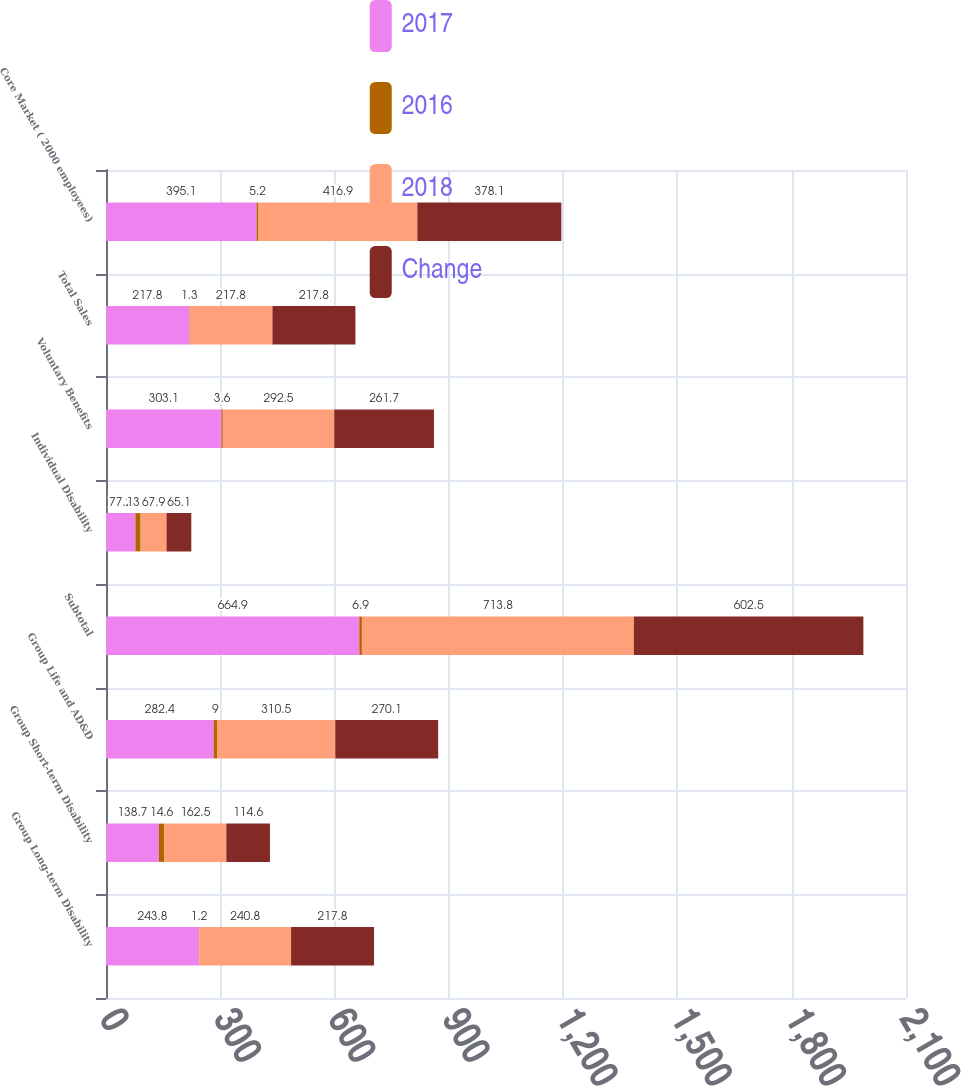Convert chart. <chart><loc_0><loc_0><loc_500><loc_500><stacked_bar_chart><ecel><fcel>Group Long-term Disability<fcel>Group Short-term Disability<fcel>Group Life and AD&D<fcel>Subtotal<fcel>Individual Disability<fcel>Voluntary Benefits<fcel>Total Sales<fcel>Core Market ( 2000 employees)<nl><fcel>2017<fcel>243.8<fcel>138.7<fcel>282.4<fcel>664.9<fcel>77.2<fcel>303.1<fcel>217.8<fcel>395.1<nl><fcel>2016<fcel>1.2<fcel>14.6<fcel>9<fcel>6.9<fcel>13.7<fcel>3.6<fcel>1.3<fcel>5.2<nl><fcel>2018<fcel>240.8<fcel>162.5<fcel>310.5<fcel>713.8<fcel>67.9<fcel>292.5<fcel>217.8<fcel>416.9<nl><fcel>Change<fcel>217.8<fcel>114.6<fcel>270.1<fcel>602.5<fcel>65.1<fcel>261.7<fcel>217.8<fcel>378.1<nl></chart> 